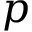<formula> <loc_0><loc_0><loc_500><loc_500>p</formula> 